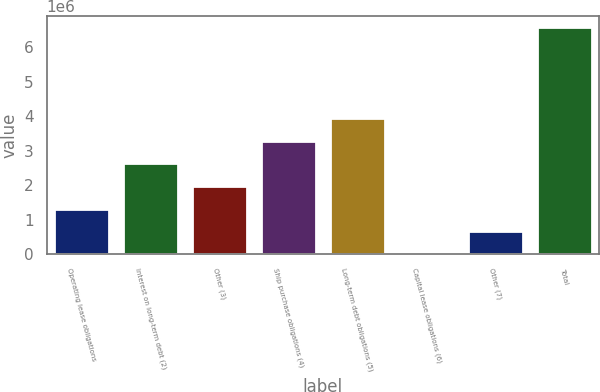Convert chart to OTSL. <chart><loc_0><loc_0><loc_500><loc_500><bar_chart><fcel>Operating lease obligations<fcel>Interest on long-term debt (2)<fcel>Other (3)<fcel>Ship purchase obligations (4)<fcel>Long-term debt obligations (5)<fcel>Capital lease obligations (6)<fcel>Other (7)<fcel>Total<nl><fcel>1.32126e+06<fcel>2.63549e+06<fcel>1.97838e+06<fcel>3.29261e+06<fcel>3.94972e+06<fcel>7031<fcel>664146<fcel>6.57818e+06<nl></chart> 